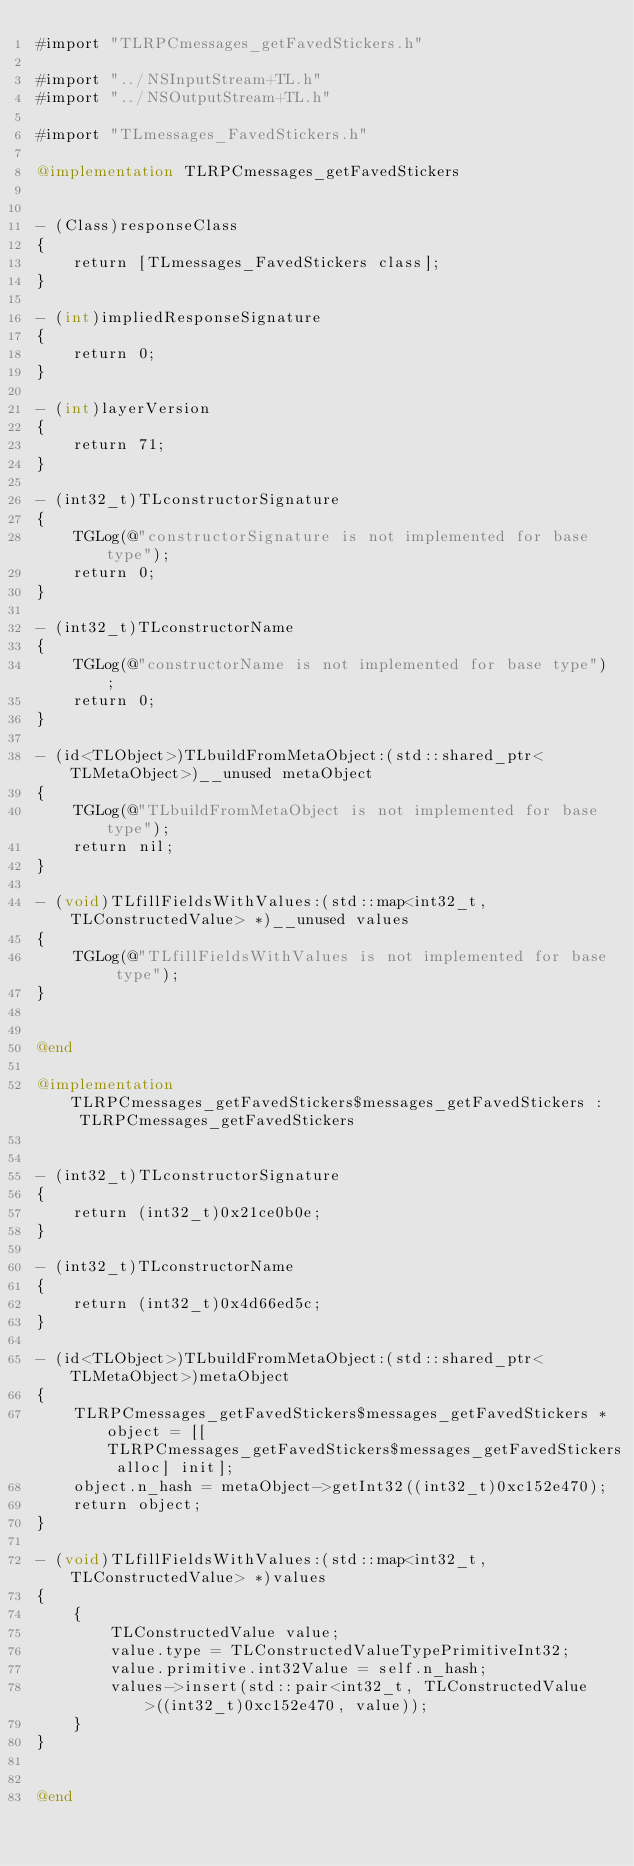Convert code to text. <code><loc_0><loc_0><loc_500><loc_500><_ObjectiveC_>#import "TLRPCmessages_getFavedStickers.h"

#import "../NSInputStream+TL.h"
#import "../NSOutputStream+TL.h"

#import "TLmessages_FavedStickers.h"

@implementation TLRPCmessages_getFavedStickers


- (Class)responseClass
{
    return [TLmessages_FavedStickers class];
}

- (int)impliedResponseSignature
{
    return 0;
}

- (int)layerVersion
{
    return 71;
}

- (int32_t)TLconstructorSignature
{
    TGLog(@"constructorSignature is not implemented for base type");
    return 0;
}

- (int32_t)TLconstructorName
{
    TGLog(@"constructorName is not implemented for base type");
    return 0;
}

- (id<TLObject>)TLbuildFromMetaObject:(std::shared_ptr<TLMetaObject>)__unused metaObject
{
    TGLog(@"TLbuildFromMetaObject is not implemented for base type");
    return nil;
}

- (void)TLfillFieldsWithValues:(std::map<int32_t, TLConstructedValue> *)__unused values
{
    TGLog(@"TLfillFieldsWithValues is not implemented for base type");
}


@end

@implementation TLRPCmessages_getFavedStickers$messages_getFavedStickers : TLRPCmessages_getFavedStickers


- (int32_t)TLconstructorSignature
{
    return (int32_t)0x21ce0b0e;
}

- (int32_t)TLconstructorName
{
    return (int32_t)0x4d66ed5c;
}

- (id<TLObject>)TLbuildFromMetaObject:(std::shared_ptr<TLMetaObject>)metaObject
{
    TLRPCmessages_getFavedStickers$messages_getFavedStickers *object = [[TLRPCmessages_getFavedStickers$messages_getFavedStickers alloc] init];
    object.n_hash = metaObject->getInt32((int32_t)0xc152e470);
    return object;
}

- (void)TLfillFieldsWithValues:(std::map<int32_t, TLConstructedValue> *)values
{
    {
        TLConstructedValue value;
        value.type = TLConstructedValueTypePrimitiveInt32;
        value.primitive.int32Value = self.n_hash;
        values->insert(std::pair<int32_t, TLConstructedValue>((int32_t)0xc152e470, value));
    }
}


@end

</code> 